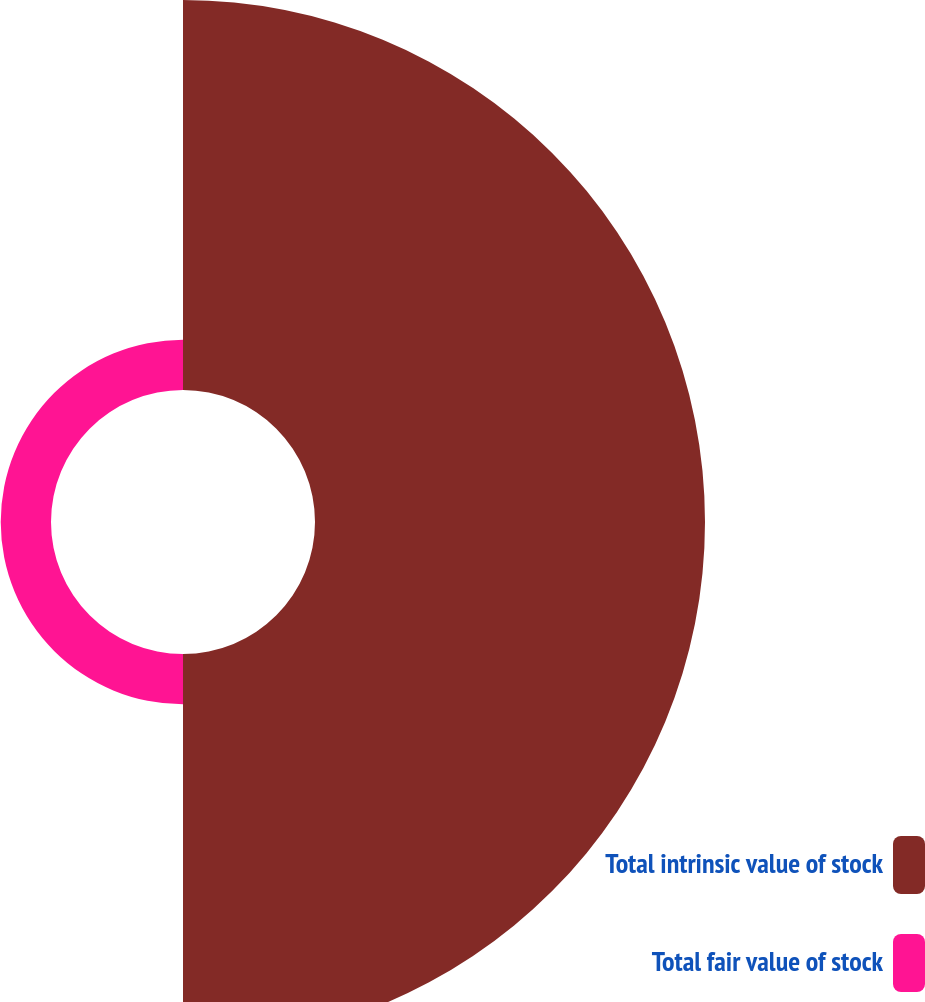Convert chart to OTSL. <chart><loc_0><loc_0><loc_500><loc_500><pie_chart><fcel>Total intrinsic value of stock<fcel>Total fair value of stock<nl><fcel>88.58%<fcel>11.42%<nl></chart> 